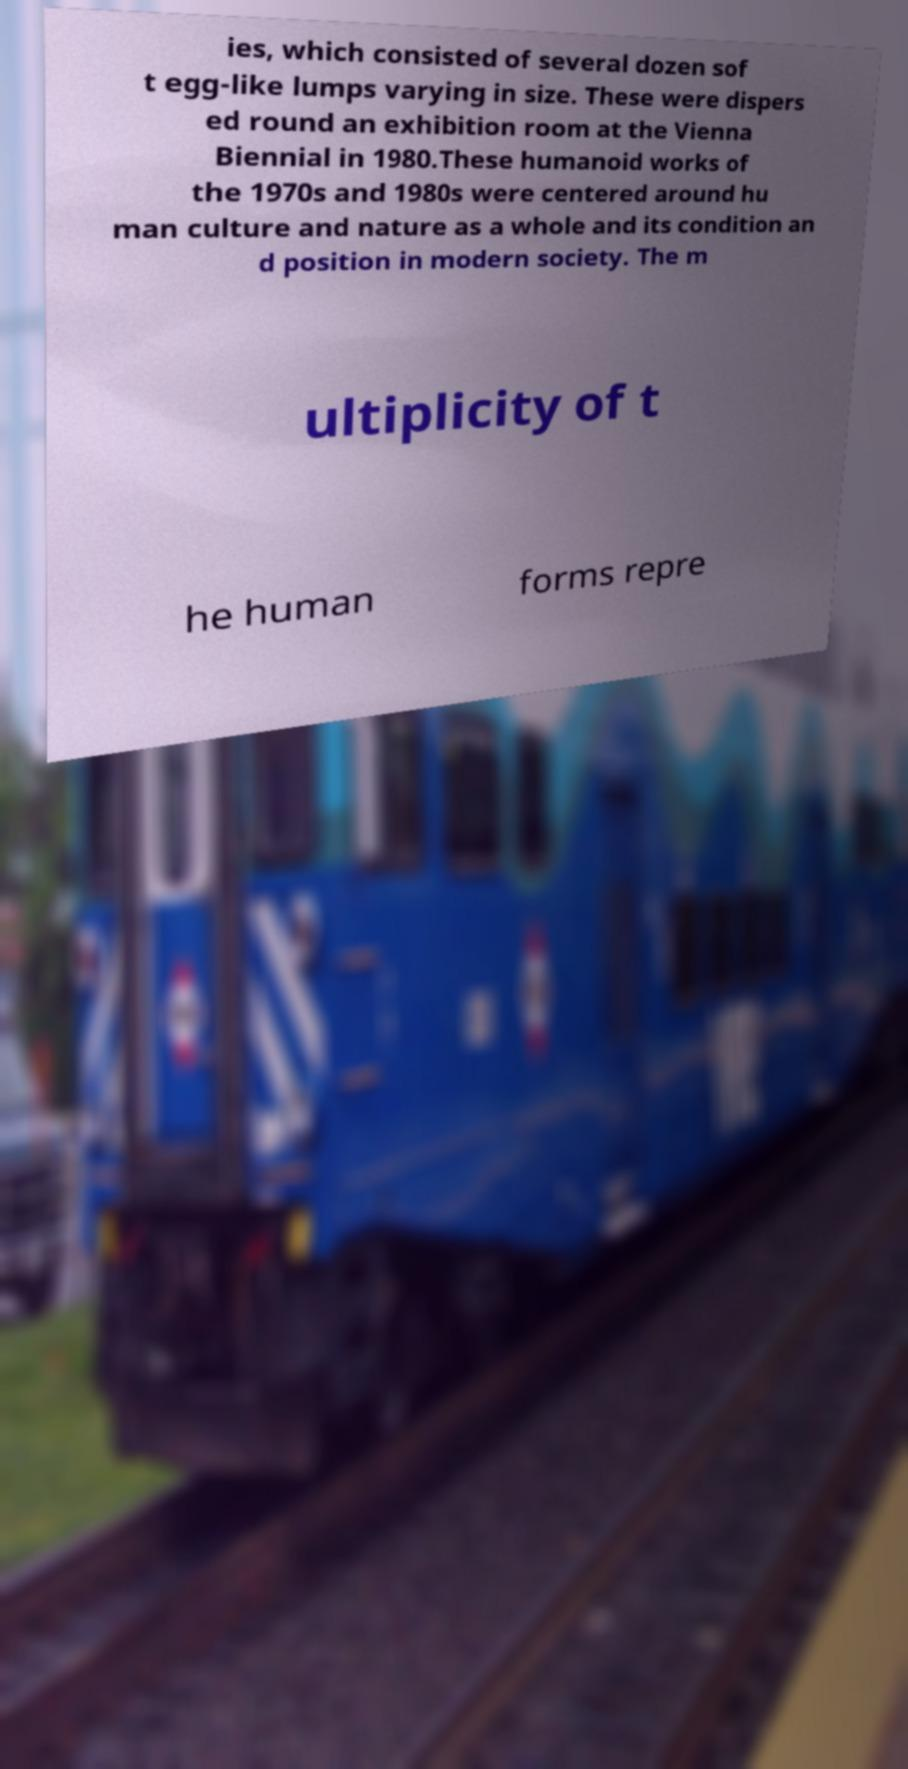There's text embedded in this image that I need extracted. Can you transcribe it verbatim? ies, which consisted of several dozen sof t egg-like lumps varying in size. These were dispers ed round an exhibition room at the Vienna Biennial in 1980.These humanoid works of the 1970s and 1980s were centered around hu man culture and nature as a whole and its condition an d position in modern society. The m ultiplicity of t he human forms repre 